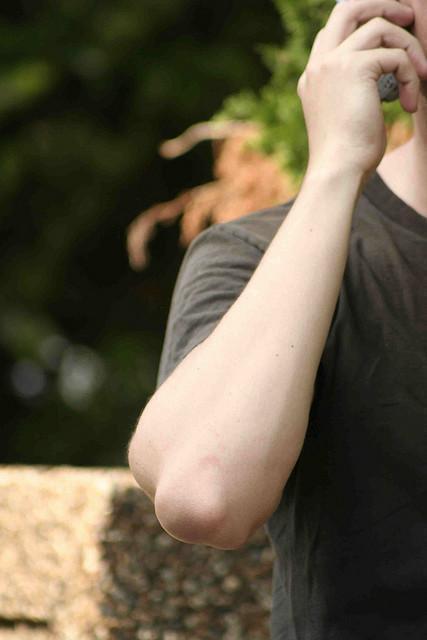How many donuts are pictured?
Give a very brief answer. 0. 